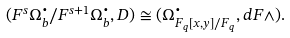Convert formula to latex. <formula><loc_0><loc_0><loc_500><loc_500>( F ^ { s } \Omega ^ { \bullet } _ { b } / F ^ { s + 1 } \Omega ^ { \bullet } _ { b } , D ) \cong ( \Omega ^ { \bullet } _ { { F } _ { q } [ x , y ] / { F } _ { q } } , d F \wedge ) .</formula> 